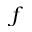Convert formula to latex. <formula><loc_0><loc_0><loc_500><loc_500>f</formula> 